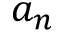<formula> <loc_0><loc_0><loc_500><loc_500>a _ { n }</formula> 